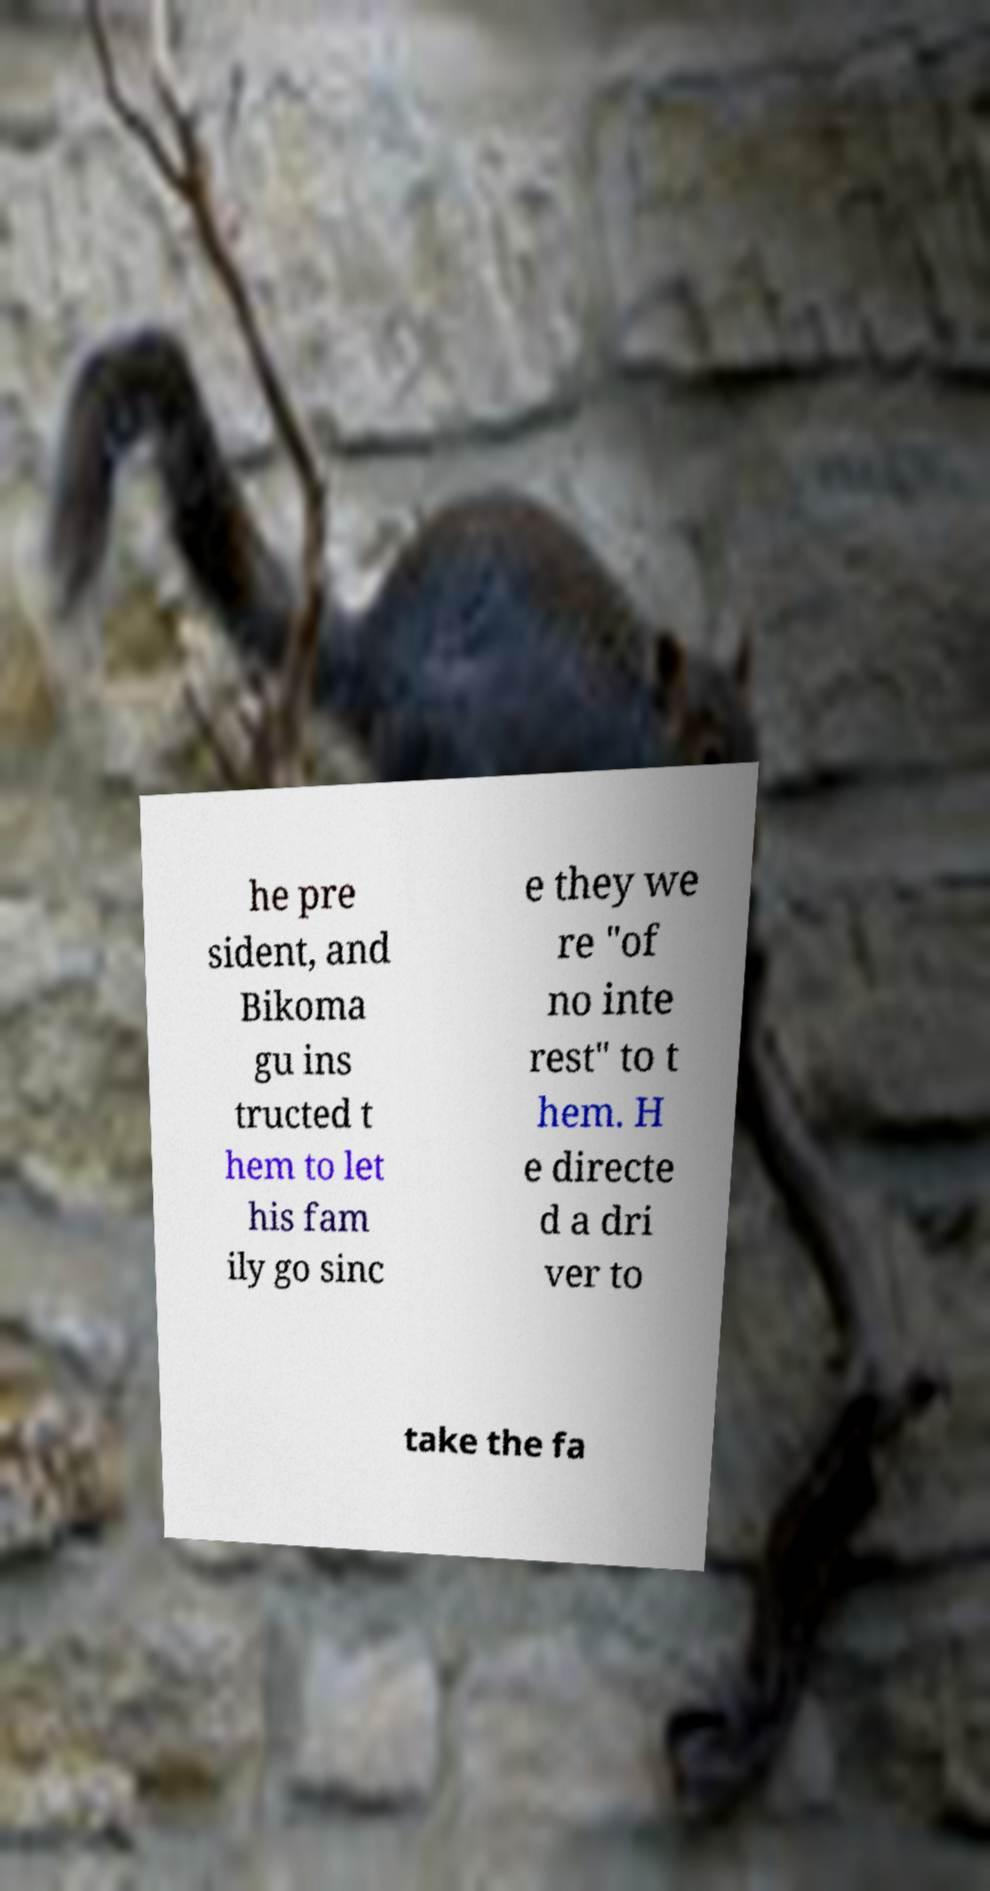Please identify and transcribe the text found in this image. he pre sident, and Bikoma gu ins tructed t hem to let his fam ily go sinc e they we re "of no inte rest" to t hem. H e directe d a dri ver to take the fa 